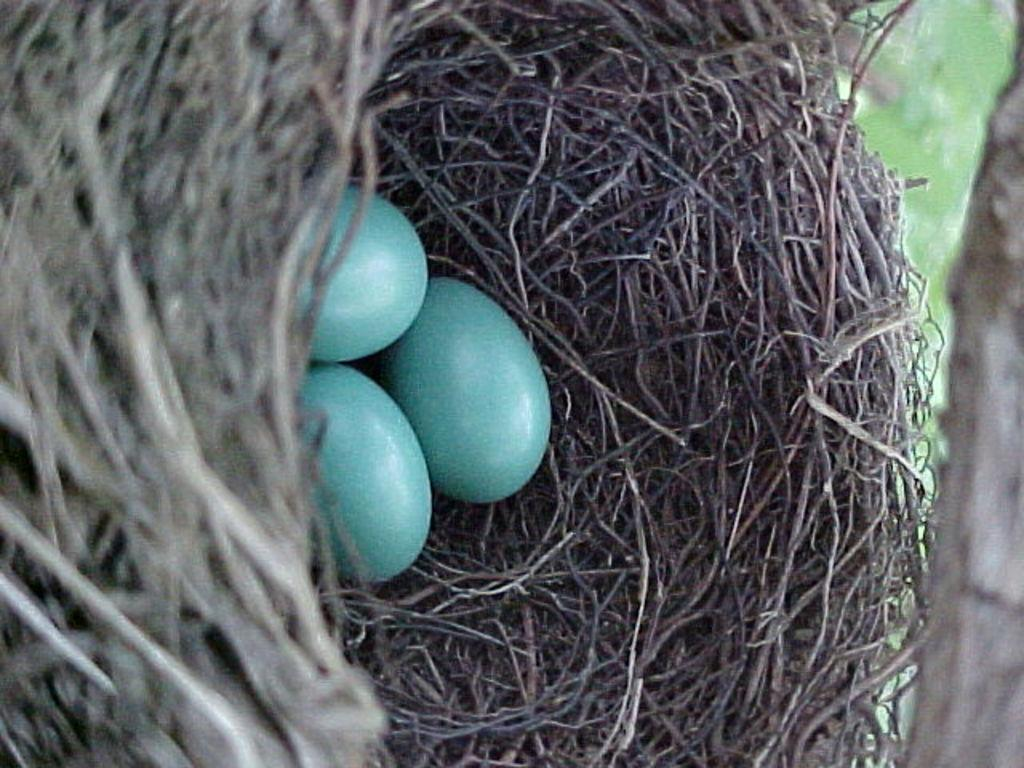What can be seen in the image? There is a nest in the image. How many eggs are in the nest? There are three eggs in the nest. What type of pot is used to balance the nest in the image? There is no pot present in the image, and the nest is not balanced on any object. 